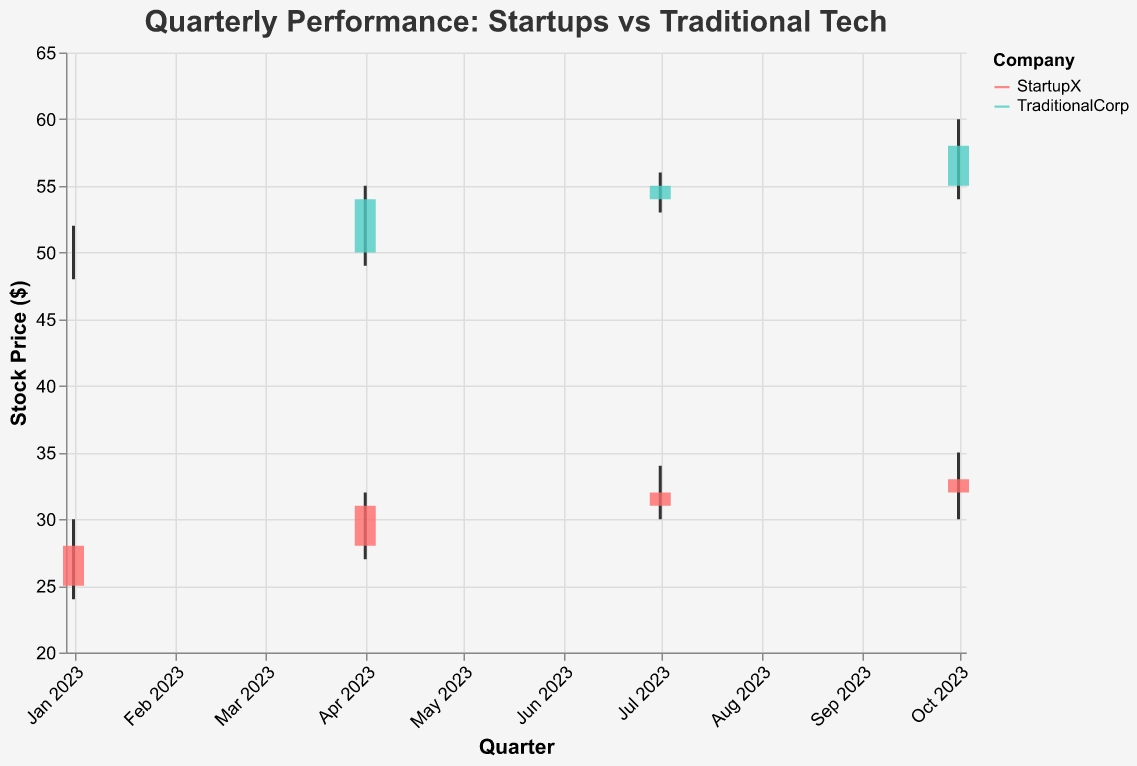How many companies are shown in the figure? There are two companies shown in the figure: "StartupX" and "TraditionalCorp." This can be identified by looking at the color legend that lists both company names.
Answer: 2 Which company has the higher stock price in the first quarter of 2023? In the first quarter (Jan 2023), "TraditionalCorp" opened at 50 and closed at 50, whereas "StartupX" opened at 25 and closed at 28. Comparing the closing prices, "TraditionalCorp" has the higher stock price.
Answer: TraditionalCorp By how much did the stock price of StartupX increase from Q1 to Q4 in 2023? StartupX's closing price in Q1 was 28, and in Q4 it was 33. The increase in stock price is calculated by subtracting the Q1 closing price from the Q4 closing price: 33 - 28 = 5.
Answer: 5 Which company experienced a larger growth in stock price in the second quarter of 2023? In Q2 (Apr 2023), "StartupX" opened at 28 and closed at 31, an increase of 3. "TraditionalCorp" opened at 50 and closed at 54, an increase of 4. Comparing these, "TraditionalCorp" experienced a larger growth.
Answer: TraditionalCorp What is the highest high recorded by each company throughout 2023? The highest high for "StartupX" is 35, recorded in Oct 2023. The highest high for "TraditionalCorp" is 60, also recorded in Oct 2023. This information is evident by looking at the highest points on the vertical lines (high values) for each company.
Answer: StartupX: 35, TraditionalCorp: 60 Which company has a consistently rising closing price throughout 2023? By looking at the closing prices for both companies across the quarters, "StartupX" shows a rise from 28 (Q1) to 31 (Q2) to 32 (Q3) to 33 (Q4). In comparison, "TraditionalCorp" also increases, but not consistently, it remains the same between Q1 and Q2 (50) then rises subsequently.
Answer: StartupX In which quarter did TraditionalCorp show the largest increase in its stock price? TraditionalCorp showed the largest increase in its stock price in Q4 (Oct 2023), where it opened at 55 and closed at 58. This is an increase of 3 compared to other quarters with smaller differences.
Answer: Q4 What is the volume trend for StartupX throughout 2023? The volume for StartupX increases consistently each quarter: 2000 in Q1, 2200 in Q2, 2300 in Q3, and 2400 in Q4. This trend indicates a gradual rise in trading volume.
Answer: Increasing How does the opening price of TraditionalCorp in Q3 compare to its closing price in Q2? The opening price of TraditionalCorp in Q3 (Jul 2023) is 54, while its closing price in Q2 (Apr 2023) is 54. Since both values are the same, the opening price in Q3 is equal to the closing price in Q2.
Answer: Equal 